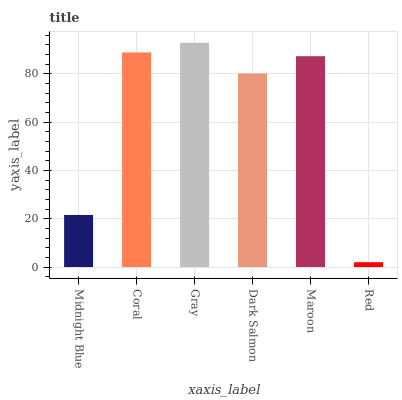Is Coral the minimum?
Answer yes or no. No. Is Coral the maximum?
Answer yes or no. No. Is Coral greater than Midnight Blue?
Answer yes or no. Yes. Is Midnight Blue less than Coral?
Answer yes or no. Yes. Is Midnight Blue greater than Coral?
Answer yes or no. No. Is Coral less than Midnight Blue?
Answer yes or no. No. Is Maroon the high median?
Answer yes or no. Yes. Is Dark Salmon the low median?
Answer yes or no. Yes. Is Midnight Blue the high median?
Answer yes or no. No. Is Gray the low median?
Answer yes or no. No. 